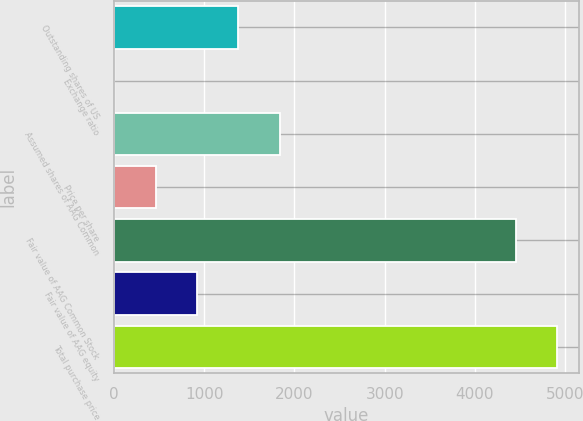Convert chart. <chart><loc_0><loc_0><loc_500><loc_500><bar_chart><fcel>Outstanding shares of US<fcel>Exchange ratio<fcel>Assumed shares of AAG Common<fcel>Price per share<fcel>Fair value of AAG Common Stock<fcel>Fair value of AAG equity<fcel>Total purchase price<nl><fcel>1378.3<fcel>1<fcel>1837.4<fcel>460.1<fcel>4451<fcel>919.2<fcel>4910.1<nl></chart> 